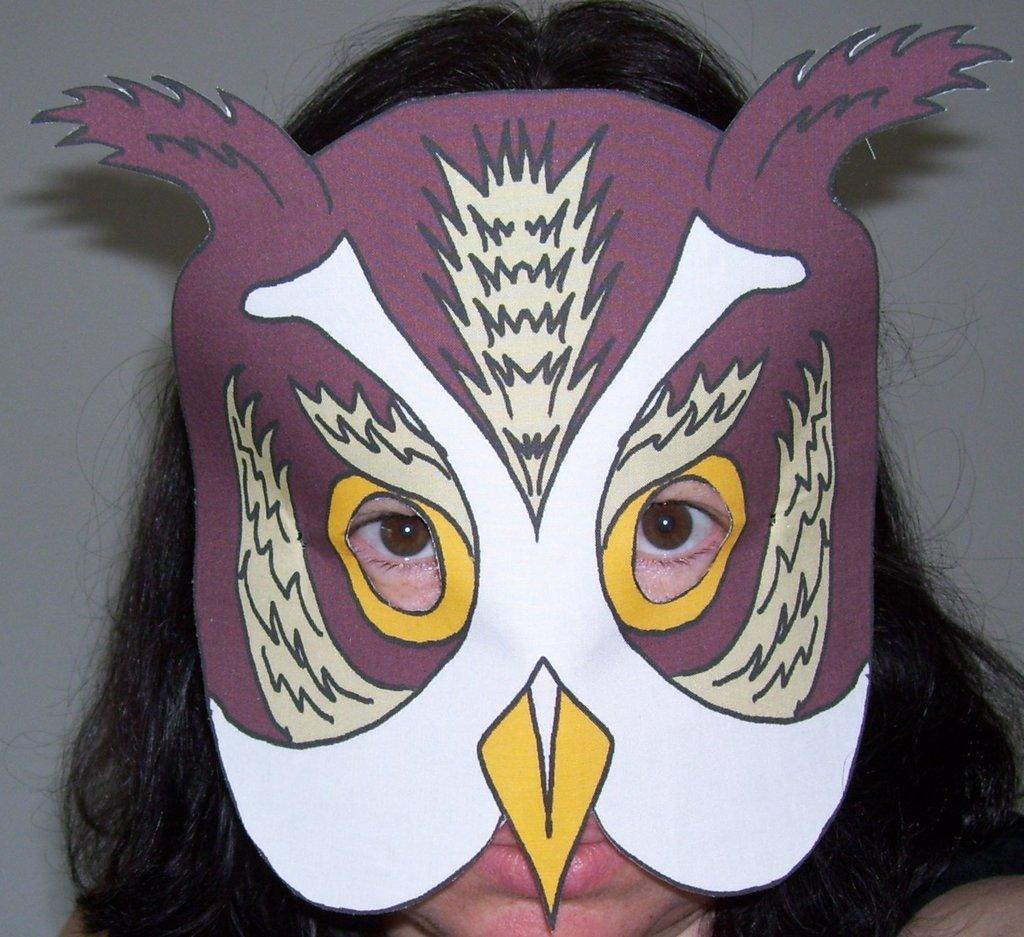Please provide a concise description of this image. In this image there is a person wearing a mask. In the background there is wall. 